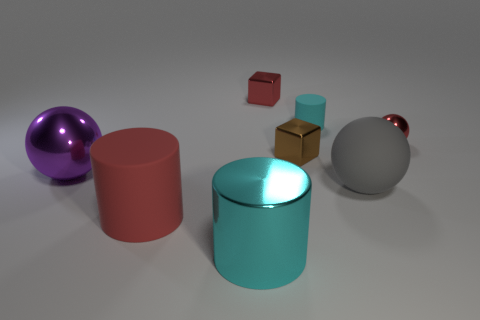Does the big cyan thing have the same shape as the large object that is behind the big gray matte sphere?
Your answer should be very brief. No. Is the number of large rubber spheres to the left of the big cyan metal cylinder less than the number of red matte cylinders that are behind the rubber sphere?
Provide a succinct answer. No. Is there anything else that has the same shape as the cyan rubber thing?
Offer a very short reply. Yes. Do the purple metal object and the big gray thing have the same shape?
Make the answer very short. Yes. Are there any other things that have the same material as the big gray ball?
Provide a short and direct response. Yes. How big is the red cube?
Make the answer very short. Small. There is a ball that is behind the large gray sphere and on the right side of the small rubber object; what is its color?
Your response must be concise. Red. Are there more tiny brown metal things than small cubes?
Provide a short and direct response. No. How many things are tiny cylinders or cylinders behind the large purple sphere?
Make the answer very short. 1. Is the size of the purple metallic object the same as the gray sphere?
Provide a short and direct response. Yes. 